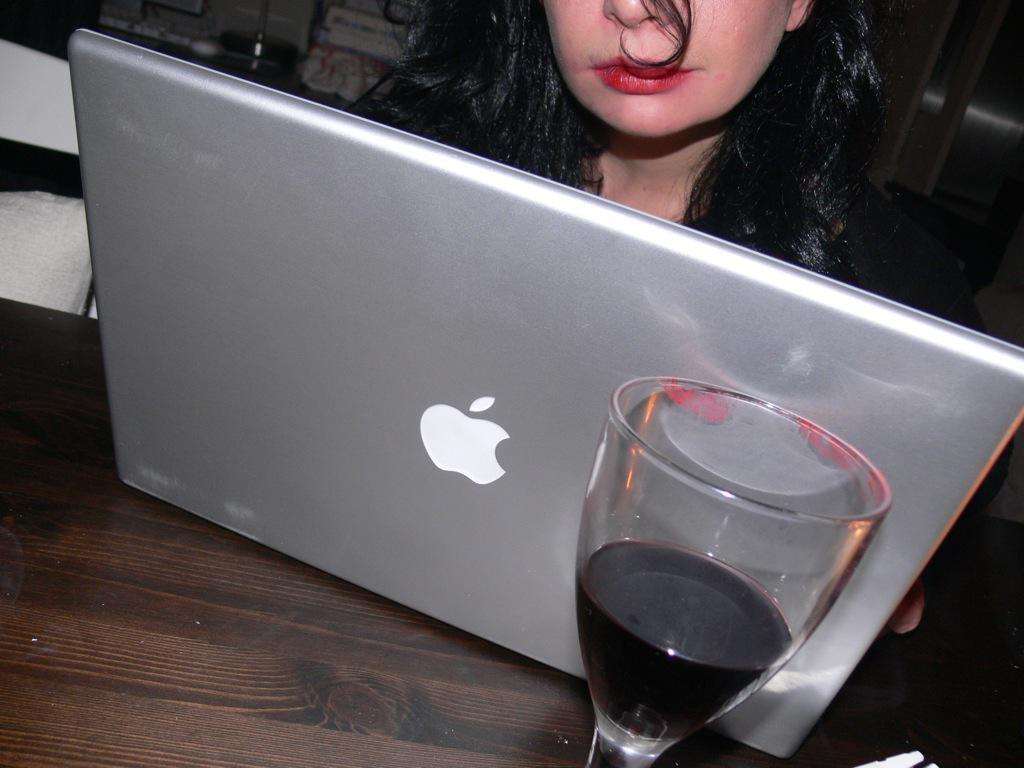What is contained in the glass that is visible in the image? There is liquid in a glass in the image. What electronic device is visible in the image? There is a laptop visible on a wooden surface in the image. Who is present in the image? A woman is present in the image. What can be seen in the background of the image? There are a few objects visible in the background. Can you see the woman's feet in the image? The image does not show the woman's feet, so it is not possible to determine if they are visible. Is the woman in the image surrounded by wilderness? The image does not depict a wilderness setting; it appears to be an indoor scene. 